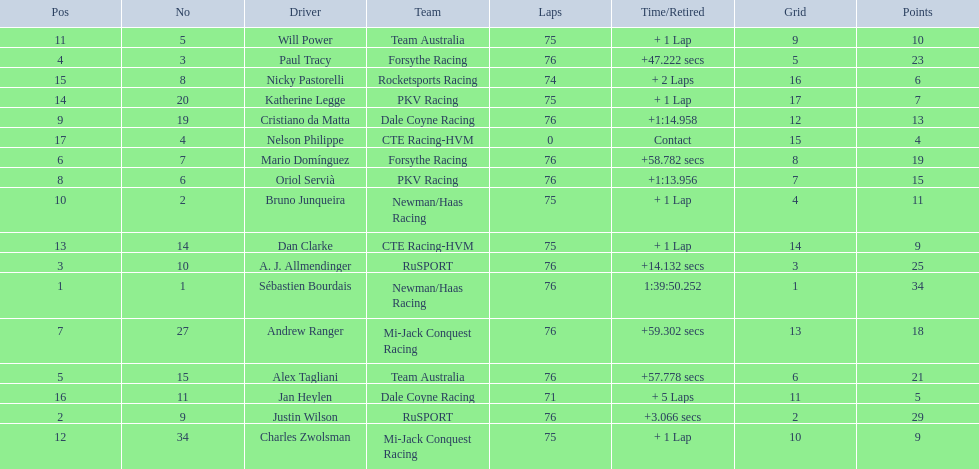How many points did charles zwolsman acquire? 9. Who else got 9 points? Dan Clarke. 